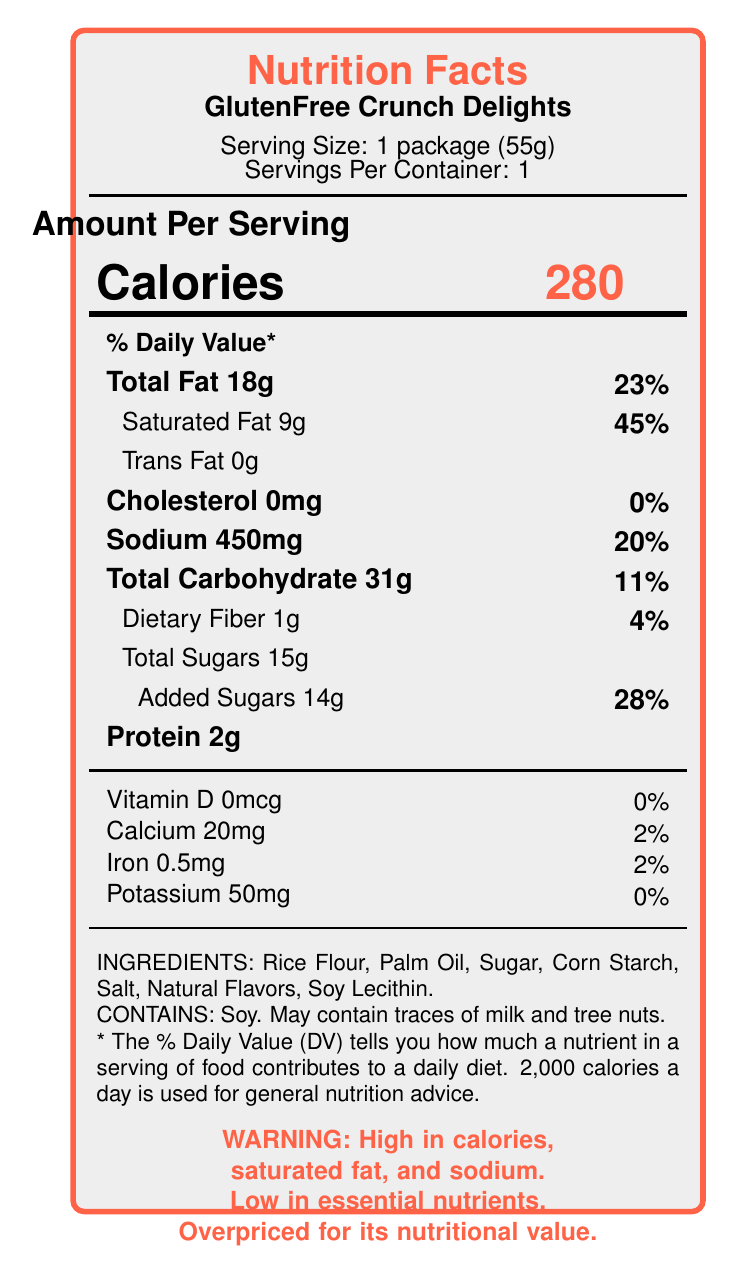what is the serving size for the GlutenFree Crunch Delights? The document lists the serving size as "1 package (55g)".
Answer: 1 package (55g) how many servings are in one container of GlutenFree Crunch Delights? The document states that there is 1 serving per container.
Answer: 1 how many calories are in one serving of GlutenFree Crunch Delights? The document shows "Calories: 280" for one serving.
Answer: 280 what is the total fat content in one serving? The document lists "Total Fat 18g".
Answer: 18g how much of the daily value* for saturated fat does one serving contain? The document indicates "Saturated Fat 9g" makes up 45% of the daily value.
Answer: 45% how much sodium does one serving contain? The document lists "Sodium 450mg".
Answer: 450mg how much added sugars does one serving contain? The document specifies "Added Sugars 14g".
Answer: 14g what percentage of the daily value does one serving of added sugars contribute? According to the document, added sugars contribute 28% of the daily value.
Answer: 28% which of the following nutrients is not present in one serving of GlutenFree Crunch Delights? A. Protein B. Fiber C. Vitamin D D. Iron The document shows "Vitamin D 0mcg" with a 0% daily value.
Answer: C. Vitamin D which ingredient is listed first on the ingredients list? A. Palm Oil B. Sugar C. Rice Flour D. Corn Starch The first ingredient listed is "Rice Flour".
Answer: C. Rice Flour does the product contain any preservatives? The marketing claims section mentions "No Preservatives."
Answer: No is there any iron in the GlutenFree Crunch Delights? The document lists "Iron 0.5mg (2%)".
Answer: Yes what allergens does this product contain? The allergen info section states "Contains: Soy. May contain traces of milk and tree nuts."
Answer: Soy, may contain traces of milk and tree nuts provide a summary of the main concerns highlighted in the document regarding this product The document emphasizes the high calorie, saturated fat, and sodium content in relation to the low nutritional value, particularly highlighting the concerns against its marketing claims and the perceived overpricing.
Answer: The GlutenFree Crunch Delights snack is high in calories (280 per serving), with excessive saturated fat (45% of daily value) and sodium (20% of daily value) content. It also has low fiber, vitamins, and essential nutrients, despite claiming to be gluten-free, with no artificial colors or preservatives. The document suggests it is overpriced for its nutritional value and highlights processed ingredients. how much protein does the GlutenFree Crunch Delights contain per serving? The document lists "Protein 2g".
Answer: 2g how would you describe the overall nutritional value of GlutenFree Crunch Delights? The document highlights the lack of essential nutrients, high calorie, high saturated fat, and high sodium content as major drawbacks, leading to the overall description of its nutritional value as poor.
Answer: Poor how many grams of trans fat does one serving contain? The document states "Trans Fat 0g".
Answer: 0g which nutrient(s) have a daily value percentage of 0%? The document lists "Vitamin D 0mcg" and "Potassium 50mg" both with a 0% daily value.
Answer: Vitamin D and Potassium does the product contain any artificial colors? The marketing claims section states "No Artificial Colors."
Answer: No how much dietary fiber does one serving of GlutenFree Crunch Delights contain? The document lists "Dietary Fiber 1g".
Answer: 1g what is the total carbohydrate content in one serving? The document states "Total Carbohydrate 31g".
Answer: 31g how much calcium is there in one serving of GlutenFree Crunch Delights? The document lists "Calcium 20mg".
Answer: 20mg what type of oil is used as an ingredient in GlutenFree Crunch Delights? The ingredients list includes "Palm Oil".
Answer: Palm Oil what does the warning message at the bottom of the document indicate? The warning message explicitly states these concerns regarding the product.
Answer: High in calories, saturated fat, and sodium. Low in essential nutrients. Overpriced for its nutritional value. what percentage of the daily value does iron in one serving contribute? The document lists "Iron 0.5mg (2%)".
Answer: 2% what is the amount of cholesterol per serving? The document lists "Cholesterol 0mg (0%)".
Answer: 0mg does the product contain any tree nuts? The allergen information states "May contain traces of milk and tree nuts," which indicates the presence is not definite.
Answer: Cannot be determined 